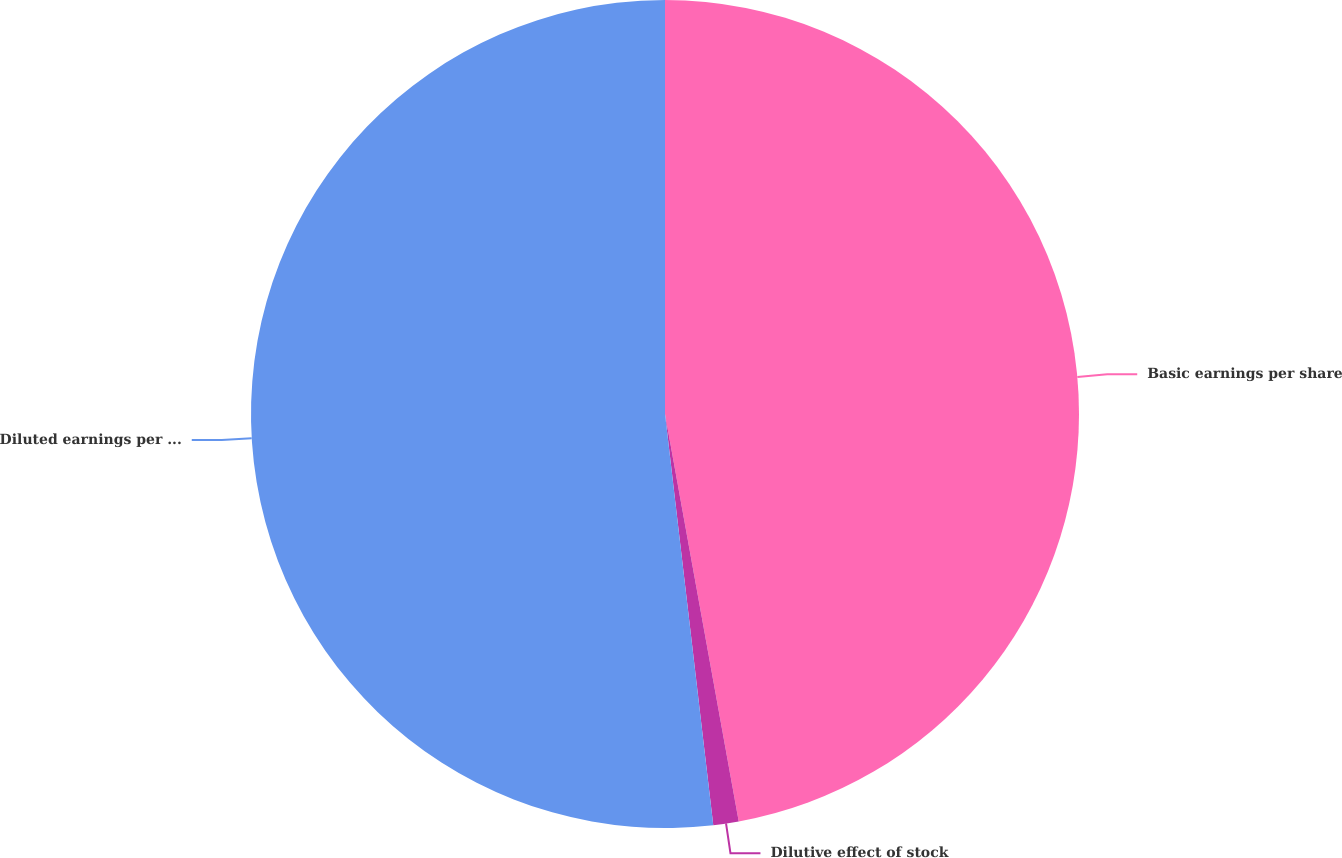Convert chart. <chart><loc_0><loc_0><loc_500><loc_500><pie_chart><fcel>Basic earnings per share<fcel>Dilutive effect of stock<fcel>Diluted earnings per share<nl><fcel>47.15%<fcel>0.99%<fcel>51.86%<nl></chart> 